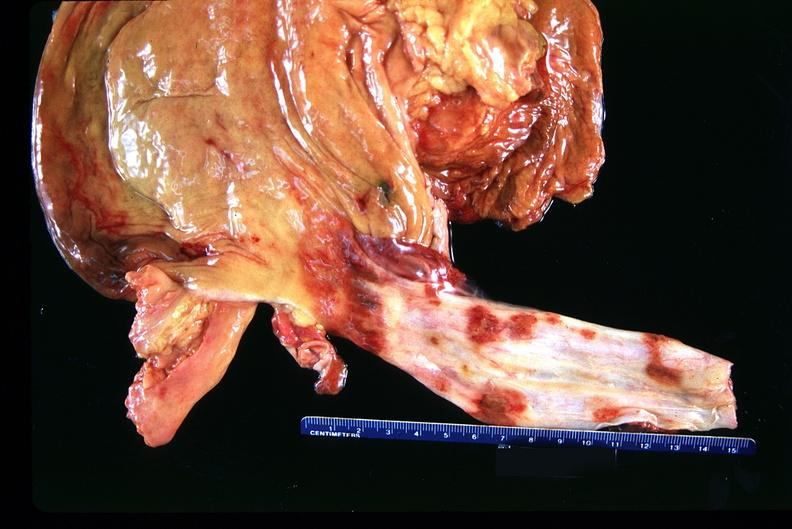does this image show stomach and esophagus, ulcers?
Answer the question using a single word or phrase. Yes 